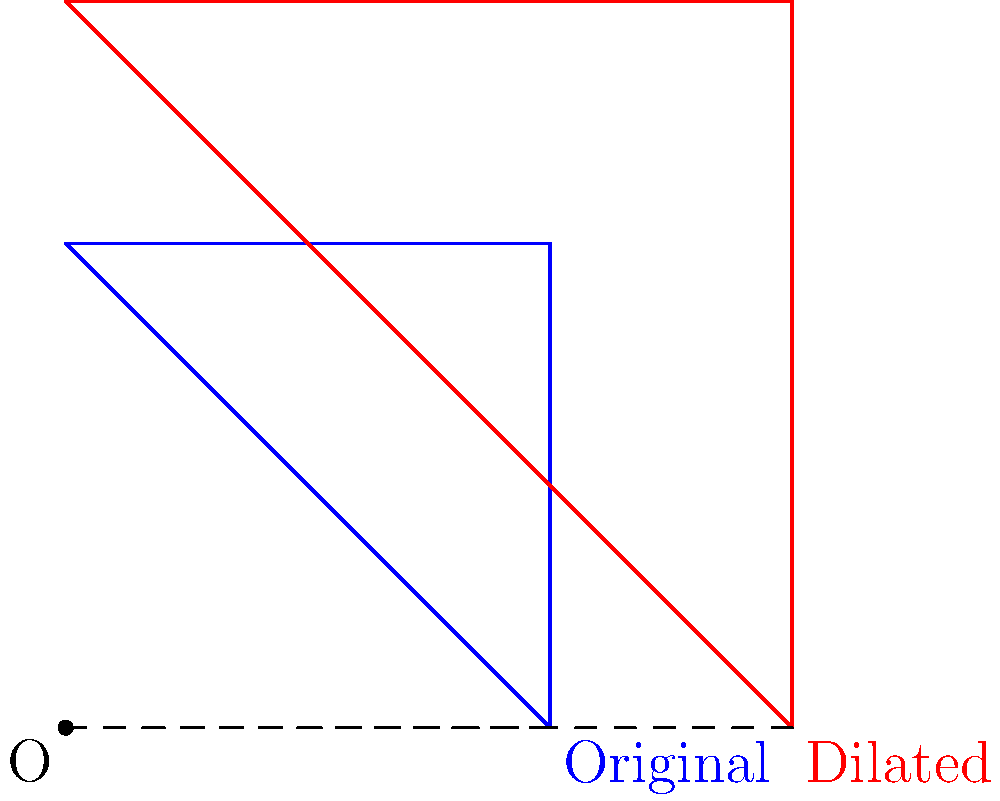A wear pattern on a salvaged camshaft is represented by a triangular shape. After dilation with a scale factor of 1.5 from the origin, the area of the wear pattern increases. If the original wear pattern had an area of 2 square inches, what is the area of the dilated wear pattern in square inches? To solve this problem, we need to understand how dilation affects the area of a shape:

1) In a dilation with scale factor $k$, the area is multiplied by $k^2$.

2) In this case, the scale factor $k = 1.5$.

3) The original area $A = 2$ square inches.

4) The new area $A'$ can be calculated as:

   $A' = k^2 \cdot A$

5) Substituting the values:

   $A' = (1.5)^2 \cdot 2$

6) Simplify:

   $A' = 2.25 \cdot 2 = 4.5$

Therefore, the area of the dilated wear pattern is 4.5 square inches.
Answer: 4.5 square inches 